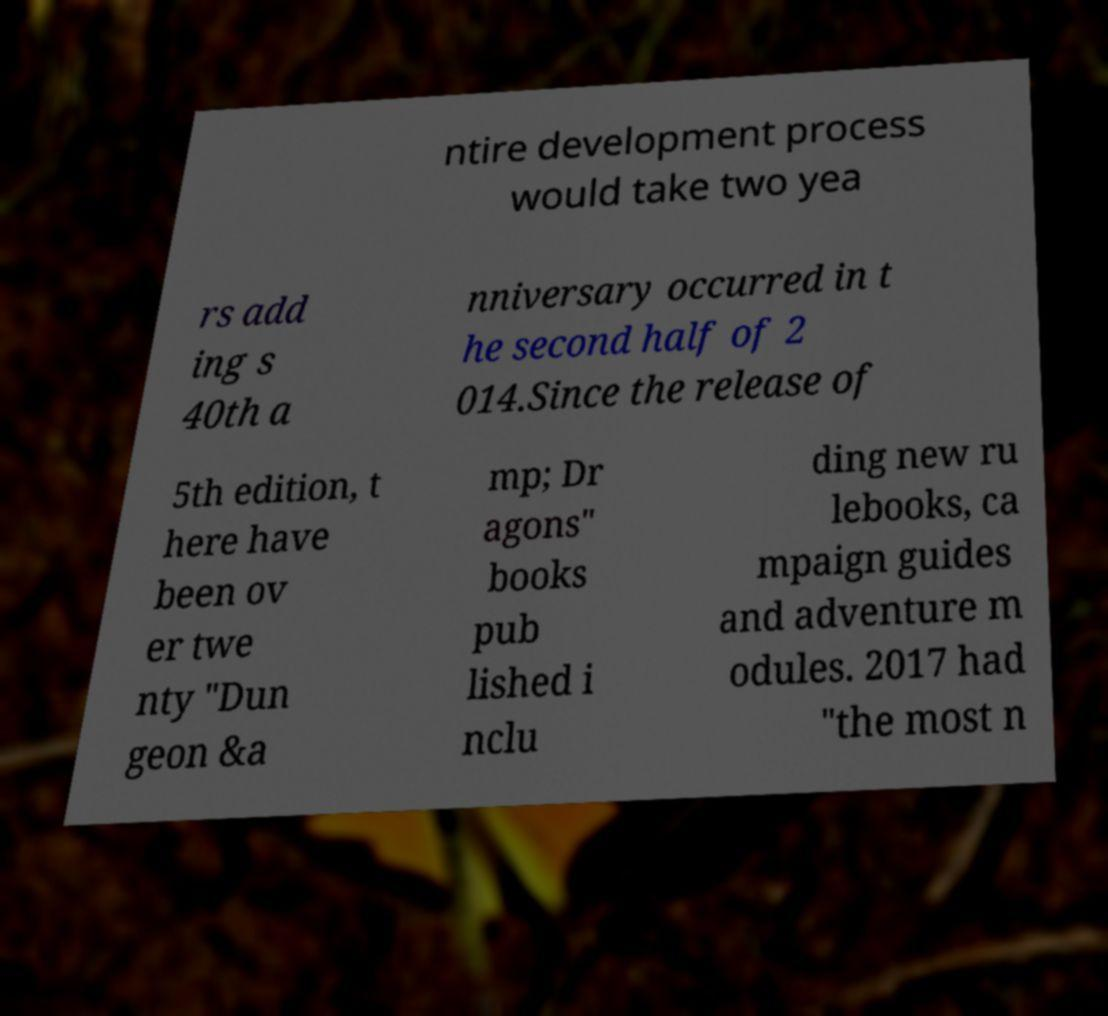Can you accurately transcribe the text from the provided image for me? ntire development process would take two yea rs add ing s 40th a nniversary occurred in t he second half of 2 014.Since the release of 5th edition, t here have been ov er twe nty "Dun geon &a mp; Dr agons" books pub lished i nclu ding new ru lebooks, ca mpaign guides and adventure m odules. 2017 had "the most n 